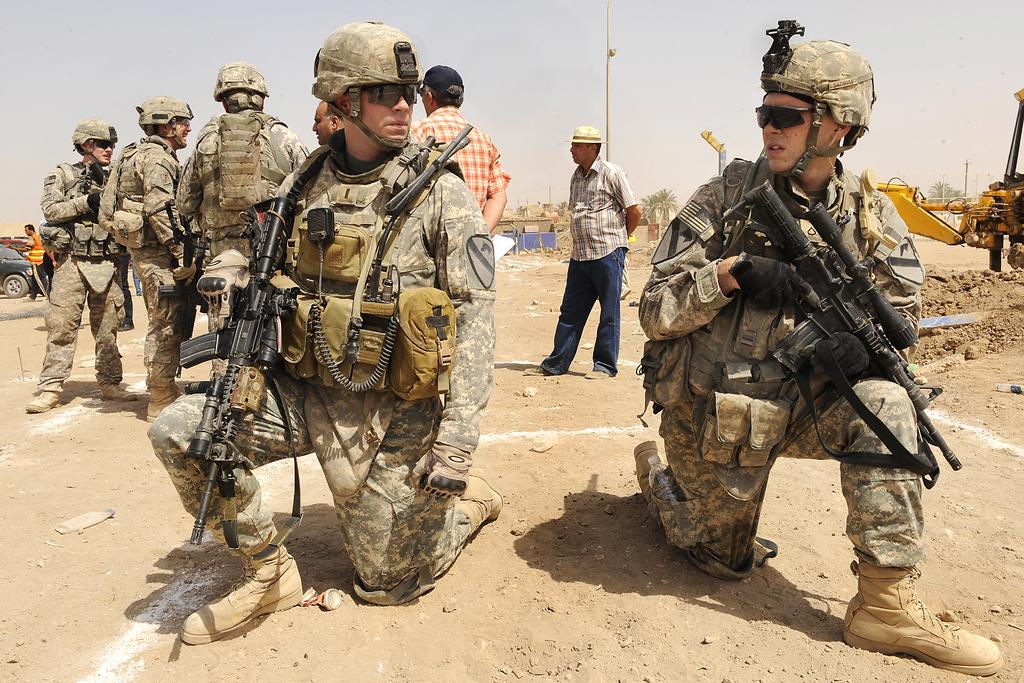Can you describe this image briefly? This picture describes about group of people, few people wore helmets and few people holding guns, in the background we can see few vehicles, trees, poles and buildings. 